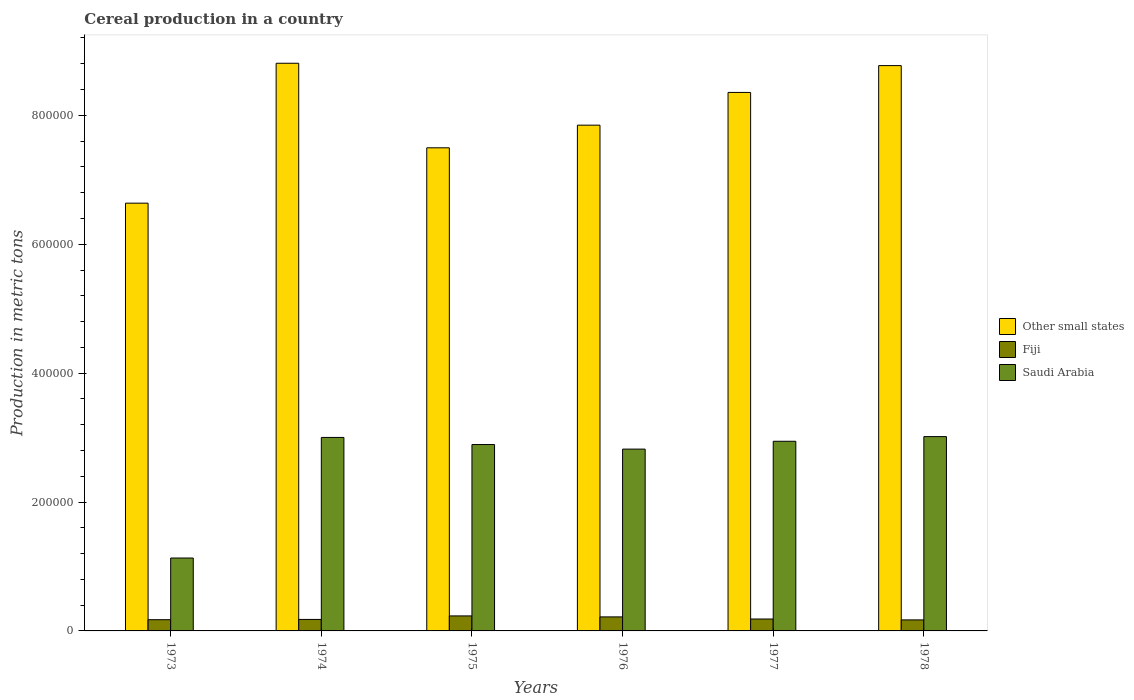How many different coloured bars are there?
Ensure brevity in your answer.  3. Are the number of bars on each tick of the X-axis equal?
Offer a terse response. Yes. How many bars are there on the 2nd tick from the left?
Offer a very short reply. 3. How many bars are there on the 4th tick from the right?
Give a very brief answer. 3. What is the label of the 3rd group of bars from the left?
Provide a succinct answer. 1975. What is the total cereal production in Fiji in 1976?
Offer a terse response. 2.18e+04. Across all years, what is the maximum total cereal production in Other small states?
Keep it short and to the point. 8.81e+05. Across all years, what is the minimum total cereal production in Other small states?
Offer a terse response. 6.64e+05. In which year was the total cereal production in Fiji maximum?
Offer a terse response. 1975. In which year was the total cereal production in Other small states minimum?
Make the answer very short. 1973. What is the total total cereal production in Other small states in the graph?
Your answer should be compact. 4.79e+06. What is the difference between the total cereal production in Fiji in 1974 and that in 1978?
Offer a very short reply. 715. What is the difference between the total cereal production in Saudi Arabia in 1977 and the total cereal production in Other small states in 1978?
Your answer should be very brief. -5.83e+05. What is the average total cereal production in Saudi Arabia per year?
Make the answer very short. 2.63e+05. In the year 1975, what is the difference between the total cereal production in Saudi Arabia and total cereal production in Other small states?
Your response must be concise. -4.60e+05. In how many years, is the total cereal production in Other small states greater than 320000 metric tons?
Offer a very short reply. 6. What is the ratio of the total cereal production in Other small states in 1975 to that in 1978?
Provide a short and direct response. 0.85. Is the total cereal production in Saudi Arabia in 1975 less than that in 1976?
Offer a terse response. No. Is the difference between the total cereal production in Saudi Arabia in 1974 and 1976 greater than the difference between the total cereal production in Other small states in 1974 and 1976?
Ensure brevity in your answer.  No. What is the difference between the highest and the second highest total cereal production in Other small states?
Your answer should be very brief. 3624. What is the difference between the highest and the lowest total cereal production in Other small states?
Your answer should be compact. 2.17e+05. In how many years, is the total cereal production in Other small states greater than the average total cereal production in Other small states taken over all years?
Your answer should be compact. 3. What does the 2nd bar from the left in 1978 represents?
Your response must be concise. Fiji. What does the 2nd bar from the right in 1978 represents?
Offer a very short reply. Fiji. Is it the case that in every year, the sum of the total cereal production in Other small states and total cereal production in Saudi Arabia is greater than the total cereal production in Fiji?
Your response must be concise. Yes. How many bars are there?
Your response must be concise. 18. Are all the bars in the graph horizontal?
Offer a very short reply. No. Are the values on the major ticks of Y-axis written in scientific E-notation?
Offer a very short reply. No. Does the graph contain any zero values?
Your answer should be compact. No. Where does the legend appear in the graph?
Keep it short and to the point. Center right. What is the title of the graph?
Your response must be concise. Cereal production in a country. What is the label or title of the Y-axis?
Provide a short and direct response. Production in metric tons. What is the Production in metric tons of Other small states in 1973?
Provide a succinct answer. 6.64e+05. What is the Production in metric tons in Fiji in 1973?
Give a very brief answer. 1.74e+04. What is the Production in metric tons of Saudi Arabia in 1973?
Your answer should be very brief. 1.13e+05. What is the Production in metric tons in Other small states in 1974?
Give a very brief answer. 8.81e+05. What is the Production in metric tons of Fiji in 1974?
Offer a very short reply. 1.78e+04. What is the Production in metric tons in Saudi Arabia in 1974?
Offer a terse response. 3.00e+05. What is the Production in metric tons in Other small states in 1975?
Your answer should be very brief. 7.50e+05. What is the Production in metric tons in Fiji in 1975?
Offer a terse response. 2.33e+04. What is the Production in metric tons of Saudi Arabia in 1975?
Make the answer very short. 2.89e+05. What is the Production in metric tons of Other small states in 1976?
Make the answer very short. 7.85e+05. What is the Production in metric tons of Fiji in 1976?
Offer a terse response. 2.18e+04. What is the Production in metric tons of Saudi Arabia in 1976?
Offer a very short reply. 2.82e+05. What is the Production in metric tons of Other small states in 1977?
Your response must be concise. 8.36e+05. What is the Production in metric tons of Fiji in 1977?
Provide a succinct answer. 1.85e+04. What is the Production in metric tons of Saudi Arabia in 1977?
Offer a terse response. 2.94e+05. What is the Production in metric tons in Other small states in 1978?
Ensure brevity in your answer.  8.77e+05. What is the Production in metric tons of Fiji in 1978?
Your answer should be very brief. 1.71e+04. What is the Production in metric tons in Saudi Arabia in 1978?
Keep it short and to the point. 3.02e+05. Across all years, what is the maximum Production in metric tons of Other small states?
Ensure brevity in your answer.  8.81e+05. Across all years, what is the maximum Production in metric tons of Fiji?
Offer a very short reply. 2.33e+04. Across all years, what is the maximum Production in metric tons in Saudi Arabia?
Your answer should be very brief. 3.02e+05. Across all years, what is the minimum Production in metric tons in Other small states?
Ensure brevity in your answer.  6.64e+05. Across all years, what is the minimum Production in metric tons of Fiji?
Provide a succinct answer. 1.71e+04. Across all years, what is the minimum Production in metric tons of Saudi Arabia?
Offer a terse response. 1.13e+05. What is the total Production in metric tons of Other small states in the graph?
Ensure brevity in your answer.  4.79e+06. What is the total Production in metric tons of Fiji in the graph?
Offer a terse response. 1.16e+05. What is the total Production in metric tons in Saudi Arabia in the graph?
Your answer should be very brief. 1.58e+06. What is the difference between the Production in metric tons of Other small states in 1973 and that in 1974?
Provide a short and direct response. -2.17e+05. What is the difference between the Production in metric tons in Fiji in 1973 and that in 1974?
Keep it short and to the point. -407. What is the difference between the Production in metric tons of Saudi Arabia in 1973 and that in 1974?
Offer a very short reply. -1.87e+05. What is the difference between the Production in metric tons of Other small states in 1973 and that in 1975?
Offer a very short reply. -8.59e+04. What is the difference between the Production in metric tons in Fiji in 1973 and that in 1975?
Offer a very short reply. -5880. What is the difference between the Production in metric tons in Saudi Arabia in 1973 and that in 1975?
Offer a very short reply. -1.76e+05. What is the difference between the Production in metric tons in Other small states in 1973 and that in 1976?
Ensure brevity in your answer.  -1.21e+05. What is the difference between the Production in metric tons of Fiji in 1973 and that in 1976?
Provide a short and direct response. -4355. What is the difference between the Production in metric tons in Saudi Arabia in 1973 and that in 1976?
Keep it short and to the point. -1.69e+05. What is the difference between the Production in metric tons of Other small states in 1973 and that in 1977?
Ensure brevity in your answer.  -1.72e+05. What is the difference between the Production in metric tons in Fiji in 1973 and that in 1977?
Provide a short and direct response. -1062. What is the difference between the Production in metric tons of Saudi Arabia in 1973 and that in 1977?
Provide a succinct answer. -1.81e+05. What is the difference between the Production in metric tons in Other small states in 1973 and that in 1978?
Make the answer very short. -2.13e+05. What is the difference between the Production in metric tons in Fiji in 1973 and that in 1978?
Provide a short and direct response. 308. What is the difference between the Production in metric tons in Saudi Arabia in 1973 and that in 1978?
Your answer should be very brief. -1.88e+05. What is the difference between the Production in metric tons in Other small states in 1974 and that in 1975?
Provide a short and direct response. 1.31e+05. What is the difference between the Production in metric tons of Fiji in 1974 and that in 1975?
Provide a short and direct response. -5473. What is the difference between the Production in metric tons of Saudi Arabia in 1974 and that in 1975?
Provide a succinct answer. 1.10e+04. What is the difference between the Production in metric tons in Other small states in 1974 and that in 1976?
Offer a very short reply. 9.61e+04. What is the difference between the Production in metric tons of Fiji in 1974 and that in 1976?
Your response must be concise. -3948. What is the difference between the Production in metric tons in Saudi Arabia in 1974 and that in 1976?
Offer a terse response. 1.81e+04. What is the difference between the Production in metric tons of Other small states in 1974 and that in 1977?
Provide a succinct answer. 4.53e+04. What is the difference between the Production in metric tons of Fiji in 1974 and that in 1977?
Provide a succinct answer. -655. What is the difference between the Production in metric tons of Saudi Arabia in 1974 and that in 1977?
Offer a terse response. 5965. What is the difference between the Production in metric tons of Other small states in 1974 and that in 1978?
Offer a terse response. 3624. What is the difference between the Production in metric tons in Fiji in 1974 and that in 1978?
Offer a very short reply. 715. What is the difference between the Production in metric tons of Saudi Arabia in 1974 and that in 1978?
Your answer should be very brief. -1283. What is the difference between the Production in metric tons in Other small states in 1975 and that in 1976?
Keep it short and to the point. -3.51e+04. What is the difference between the Production in metric tons of Fiji in 1975 and that in 1976?
Give a very brief answer. 1525. What is the difference between the Production in metric tons of Saudi Arabia in 1975 and that in 1976?
Ensure brevity in your answer.  7080. What is the difference between the Production in metric tons of Other small states in 1975 and that in 1977?
Provide a short and direct response. -8.59e+04. What is the difference between the Production in metric tons in Fiji in 1975 and that in 1977?
Keep it short and to the point. 4818. What is the difference between the Production in metric tons of Saudi Arabia in 1975 and that in 1977?
Your answer should be very brief. -5085. What is the difference between the Production in metric tons of Other small states in 1975 and that in 1978?
Your response must be concise. -1.28e+05. What is the difference between the Production in metric tons of Fiji in 1975 and that in 1978?
Your response must be concise. 6188. What is the difference between the Production in metric tons in Saudi Arabia in 1975 and that in 1978?
Provide a succinct answer. -1.23e+04. What is the difference between the Production in metric tons in Other small states in 1976 and that in 1977?
Make the answer very short. -5.08e+04. What is the difference between the Production in metric tons in Fiji in 1976 and that in 1977?
Ensure brevity in your answer.  3293. What is the difference between the Production in metric tons of Saudi Arabia in 1976 and that in 1977?
Ensure brevity in your answer.  -1.22e+04. What is the difference between the Production in metric tons in Other small states in 1976 and that in 1978?
Keep it short and to the point. -9.24e+04. What is the difference between the Production in metric tons of Fiji in 1976 and that in 1978?
Your answer should be very brief. 4663. What is the difference between the Production in metric tons in Saudi Arabia in 1976 and that in 1978?
Ensure brevity in your answer.  -1.94e+04. What is the difference between the Production in metric tons of Other small states in 1977 and that in 1978?
Offer a terse response. -4.16e+04. What is the difference between the Production in metric tons of Fiji in 1977 and that in 1978?
Offer a very short reply. 1370. What is the difference between the Production in metric tons of Saudi Arabia in 1977 and that in 1978?
Offer a terse response. -7248. What is the difference between the Production in metric tons of Other small states in 1973 and the Production in metric tons of Fiji in 1974?
Your response must be concise. 6.46e+05. What is the difference between the Production in metric tons in Other small states in 1973 and the Production in metric tons in Saudi Arabia in 1974?
Offer a very short reply. 3.63e+05. What is the difference between the Production in metric tons in Fiji in 1973 and the Production in metric tons in Saudi Arabia in 1974?
Give a very brief answer. -2.83e+05. What is the difference between the Production in metric tons in Other small states in 1973 and the Production in metric tons in Fiji in 1975?
Offer a terse response. 6.40e+05. What is the difference between the Production in metric tons in Other small states in 1973 and the Production in metric tons in Saudi Arabia in 1975?
Provide a succinct answer. 3.75e+05. What is the difference between the Production in metric tons of Fiji in 1973 and the Production in metric tons of Saudi Arabia in 1975?
Keep it short and to the point. -2.72e+05. What is the difference between the Production in metric tons in Other small states in 1973 and the Production in metric tons in Fiji in 1976?
Ensure brevity in your answer.  6.42e+05. What is the difference between the Production in metric tons in Other small states in 1973 and the Production in metric tons in Saudi Arabia in 1976?
Ensure brevity in your answer.  3.82e+05. What is the difference between the Production in metric tons in Fiji in 1973 and the Production in metric tons in Saudi Arabia in 1976?
Offer a very short reply. -2.65e+05. What is the difference between the Production in metric tons in Other small states in 1973 and the Production in metric tons in Fiji in 1977?
Offer a very short reply. 6.45e+05. What is the difference between the Production in metric tons in Other small states in 1973 and the Production in metric tons in Saudi Arabia in 1977?
Your answer should be compact. 3.69e+05. What is the difference between the Production in metric tons of Fiji in 1973 and the Production in metric tons of Saudi Arabia in 1977?
Make the answer very short. -2.77e+05. What is the difference between the Production in metric tons of Other small states in 1973 and the Production in metric tons of Fiji in 1978?
Your response must be concise. 6.47e+05. What is the difference between the Production in metric tons of Other small states in 1973 and the Production in metric tons of Saudi Arabia in 1978?
Ensure brevity in your answer.  3.62e+05. What is the difference between the Production in metric tons of Fiji in 1973 and the Production in metric tons of Saudi Arabia in 1978?
Your answer should be compact. -2.84e+05. What is the difference between the Production in metric tons of Other small states in 1974 and the Production in metric tons of Fiji in 1975?
Your answer should be compact. 8.58e+05. What is the difference between the Production in metric tons of Other small states in 1974 and the Production in metric tons of Saudi Arabia in 1975?
Your answer should be very brief. 5.92e+05. What is the difference between the Production in metric tons in Fiji in 1974 and the Production in metric tons in Saudi Arabia in 1975?
Give a very brief answer. -2.71e+05. What is the difference between the Production in metric tons of Other small states in 1974 and the Production in metric tons of Fiji in 1976?
Your answer should be very brief. 8.59e+05. What is the difference between the Production in metric tons in Other small states in 1974 and the Production in metric tons in Saudi Arabia in 1976?
Provide a short and direct response. 5.99e+05. What is the difference between the Production in metric tons of Fiji in 1974 and the Production in metric tons of Saudi Arabia in 1976?
Your response must be concise. -2.64e+05. What is the difference between the Production in metric tons of Other small states in 1974 and the Production in metric tons of Fiji in 1977?
Your answer should be very brief. 8.62e+05. What is the difference between the Production in metric tons of Other small states in 1974 and the Production in metric tons of Saudi Arabia in 1977?
Your response must be concise. 5.87e+05. What is the difference between the Production in metric tons in Fiji in 1974 and the Production in metric tons in Saudi Arabia in 1977?
Your answer should be very brief. -2.76e+05. What is the difference between the Production in metric tons in Other small states in 1974 and the Production in metric tons in Fiji in 1978?
Make the answer very short. 8.64e+05. What is the difference between the Production in metric tons in Other small states in 1974 and the Production in metric tons in Saudi Arabia in 1978?
Your answer should be compact. 5.79e+05. What is the difference between the Production in metric tons in Fiji in 1974 and the Production in metric tons in Saudi Arabia in 1978?
Offer a terse response. -2.84e+05. What is the difference between the Production in metric tons of Other small states in 1975 and the Production in metric tons of Fiji in 1976?
Provide a short and direct response. 7.28e+05. What is the difference between the Production in metric tons of Other small states in 1975 and the Production in metric tons of Saudi Arabia in 1976?
Provide a short and direct response. 4.68e+05. What is the difference between the Production in metric tons in Fiji in 1975 and the Production in metric tons in Saudi Arabia in 1976?
Keep it short and to the point. -2.59e+05. What is the difference between the Production in metric tons in Other small states in 1975 and the Production in metric tons in Fiji in 1977?
Offer a very short reply. 7.31e+05. What is the difference between the Production in metric tons in Other small states in 1975 and the Production in metric tons in Saudi Arabia in 1977?
Make the answer very short. 4.55e+05. What is the difference between the Production in metric tons in Fiji in 1975 and the Production in metric tons in Saudi Arabia in 1977?
Keep it short and to the point. -2.71e+05. What is the difference between the Production in metric tons in Other small states in 1975 and the Production in metric tons in Fiji in 1978?
Your answer should be very brief. 7.33e+05. What is the difference between the Production in metric tons of Other small states in 1975 and the Production in metric tons of Saudi Arabia in 1978?
Your answer should be compact. 4.48e+05. What is the difference between the Production in metric tons in Fiji in 1975 and the Production in metric tons in Saudi Arabia in 1978?
Your answer should be very brief. -2.78e+05. What is the difference between the Production in metric tons in Other small states in 1976 and the Production in metric tons in Fiji in 1977?
Make the answer very short. 7.66e+05. What is the difference between the Production in metric tons of Other small states in 1976 and the Production in metric tons of Saudi Arabia in 1977?
Make the answer very short. 4.90e+05. What is the difference between the Production in metric tons of Fiji in 1976 and the Production in metric tons of Saudi Arabia in 1977?
Offer a very short reply. -2.73e+05. What is the difference between the Production in metric tons in Other small states in 1976 and the Production in metric tons in Fiji in 1978?
Ensure brevity in your answer.  7.68e+05. What is the difference between the Production in metric tons of Other small states in 1976 and the Production in metric tons of Saudi Arabia in 1978?
Your response must be concise. 4.83e+05. What is the difference between the Production in metric tons of Fiji in 1976 and the Production in metric tons of Saudi Arabia in 1978?
Provide a short and direct response. -2.80e+05. What is the difference between the Production in metric tons of Other small states in 1977 and the Production in metric tons of Fiji in 1978?
Keep it short and to the point. 8.18e+05. What is the difference between the Production in metric tons of Other small states in 1977 and the Production in metric tons of Saudi Arabia in 1978?
Offer a terse response. 5.34e+05. What is the difference between the Production in metric tons of Fiji in 1977 and the Production in metric tons of Saudi Arabia in 1978?
Your answer should be compact. -2.83e+05. What is the average Production in metric tons in Other small states per year?
Provide a succinct answer. 7.99e+05. What is the average Production in metric tons in Fiji per year?
Give a very brief answer. 1.93e+04. What is the average Production in metric tons of Saudi Arabia per year?
Keep it short and to the point. 2.63e+05. In the year 1973, what is the difference between the Production in metric tons in Other small states and Production in metric tons in Fiji?
Provide a succinct answer. 6.46e+05. In the year 1973, what is the difference between the Production in metric tons in Other small states and Production in metric tons in Saudi Arabia?
Keep it short and to the point. 5.51e+05. In the year 1973, what is the difference between the Production in metric tons in Fiji and Production in metric tons in Saudi Arabia?
Ensure brevity in your answer.  -9.57e+04. In the year 1974, what is the difference between the Production in metric tons of Other small states and Production in metric tons of Fiji?
Offer a terse response. 8.63e+05. In the year 1974, what is the difference between the Production in metric tons of Other small states and Production in metric tons of Saudi Arabia?
Give a very brief answer. 5.81e+05. In the year 1974, what is the difference between the Production in metric tons in Fiji and Production in metric tons in Saudi Arabia?
Provide a succinct answer. -2.82e+05. In the year 1975, what is the difference between the Production in metric tons in Other small states and Production in metric tons in Fiji?
Provide a short and direct response. 7.26e+05. In the year 1975, what is the difference between the Production in metric tons of Other small states and Production in metric tons of Saudi Arabia?
Your answer should be very brief. 4.60e+05. In the year 1975, what is the difference between the Production in metric tons in Fiji and Production in metric tons in Saudi Arabia?
Give a very brief answer. -2.66e+05. In the year 1976, what is the difference between the Production in metric tons of Other small states and Production in metric tons of Fiji?
Your response must be concise. 7.63e+05. In the year 1976, what is the difference between the Production in metric tons in Other small states and Production in metric tons in Saudi Arabia?
Make the answer very short. 5.03e+05. In the year 1976, what is the difference between the Production in metric tons in Fiji and Production in metric tons in Saudi Arabia?
Your response must be concise. -2.60e+05. In the year 1977, what is the difference between the Production in metric tons in Other small states and Production in metric tons in Fiji?
Provide a succinct answer. 8.17e+05. In the year 1977, what is the difference between the Production in metric tons in Other small states and Production in metric tons in Saudi Arabia?
Provide a succinct answer. 5.41e+05. In the year 1977, what is the difference between the Production in metric tons in Fiji and Production in metric tons in Saudi Arabia?
Your response must be concise. -2.76e+05. In the year 1978, what is the difference between the Production in metric tons in Other small states and Production in metric tons in Fiji?
Your response must be concise. 8.60e+05. In the year 1978, what is the difference between the Production in metric tons in Other small states and Production in metric tons in Saudi Arabia?
Make the answer very short. 5.76e+05. In the year 1978, what is the difference between the Production in metric tons of Fiji and Production in metric tons of Saudi Arabia?
Your response must be concise. -2.84e+05. What is the ratio of the Production in metric tons of Other small states in 1973 to that in 1974?
Your answer should be very brief. 0.75. What is the ratio of the Production in metric tons in Fiji in 1973 to that in 1974?
Make the answer very short. 0.98. What is the ratio of the Production in metric tons of Saudi Arabia in 1973 to that in 1974?
Your answer should be very brief. 0.38. What is the ratio of the Production in metric tons of Other small states in 1973 to that in 1975?
Keep it short and to the point. 0.89. What is the ratio of the Production in metric tons in Fiji in 1973 to that in 1975?
Offer a very short reply. 0.75. What is the ratio of the Production in metric tons in Saudi Arabia in 1973 to that in 1975?
Provide a short and direct response. 0.39. What is the ratio of the Production in metric tons in Other small states in 1973 to that in 1976?
Provide a succinct answer. 0.85. What is the ratio of the Production in metric tons of Fiji in 1973 to that in 1976?
Provide a short and direct response. 0.8. What is the ratio of the Production in metric tons in Saudi Arabia in 1973 to that in 1976?
Your answer should be very brief. 0.4. What is the ratio of the Production in metric tons of Other small states in 1973 to that in 1977?
Ensure brevity in your answer.  0.79. What is the ratio of the Production in metric tons of Fiji in 1973 to that in 1977?
Ensure brevity in your answer.  0.94. What is the ratio of the Production in metric tons in Saudi Arabia in 1973 to that in 1977?
Provide a short and direct response. 0.38. What is the ratio of the Production in metric tons in Other small states in 1973 to that in 1978?
Your answer should be compact. 0.76. What is the ratio of the Production in metric tons of Saudi Arabia in 1973 to that in 1978?
Your response must be concise. 0.38. What is the ratio of the Production in metric tons of Other small states in 1974 to that in 1975?
Offer a terse response. 1.18. What is the ratio of the Production in metric tons of Fiji in 1974 to that in 1975?
Offer a terse response. 0.77. What is the ratio of the Production in metric tons of Saudi Arabia in 1974 to that in 1975?
Provide a succinct answer. 1.04. What is the ratio of the Production in metric tons in Other small states in 1974 to that in 1976?
Your response must be concise. 1.12. What is the ratio of the Production in metric tons of Fiji in 1974 to that in 1976?
Offer a very short reply. 0.82. What is the ratio of the Production in metric tons of Saudi Arabia in 1974 to that in 1976?
Your response must be concise. 1.06. What is the ratio of the Production in metric tons of Other small states in 1974 to that in 1977?
Provide a short and direct response. 1.05. What is the ratio of the Production in metric tons in Fiji in 1974 to that in 1977?
Provide a short and direct response. 0.96. What is the ratio of the Production in metric tons in Saudi Arabia in 1974 to that in 1977?
Make the answer very short. 1.02. What is the ratio of the Production in metric tons in Fiji in 1974 to that in 1978?
Your answer should be very brief. 1.04. What is the ratio of the Production in metric tons of Saudi Arabia in 1974 to that in 1978?
Ensure brevity in your answer.  1. What is the ratio of the Production in metric tons of Other small states in 1975 to that in 1976?
Your answer should be very brief. 0.96. What is the ratio of the Production in metric tons in Fiji in 1975 to that in 1976?
Your answer should be very brief. 1.07. What is the ratio of the Production in metric tons of Saudi Arabia in 1975 to that in 1976?
Your answer should be compact. 1.03. What is the ratio of the Production in metric tons in Other small states in 1975 to that in 1977?
Offer a terse response. 0.9. What is the ratio of the Production in metric tons of Fiji in 1975 to that in 1977?
Offer a very short reply. 1.26. What is the ratio of the Production in metric tons in Saudi Arabia in 1975 to that in 1977?
Your response must be concise. 0.98. What is the ratio of the Production in metric tons in Other small states in 1975 to that in 1978?
Provide a succinct answer. 0.85. What is the ratio of the Production in metric tons of Fiji in 1975 to that in 1978?
Offer a terse response. 1.36. What is the ratio of the Production in metric tons in Saudi Arabia in 1975 to that in 1978?
Give a very brief answer. 0.96. What is the ratio of the Production in metric tons of Other small states in 1976 to that in 1977?
Your response must be concise. 0.94. What is the ratio of the Production in metric tons in Fiji in 1976 to that in 1977?
Provide a succinct answer. 1.18. What is the ratio of the Production in metric tons in Saudi Arabia in 1976 to that in 1977?
Give a very brief answer. 0.96. What is the ratio of the Production in metric tons of Other small states in 1976 to that in 1978?
Provide a succinct answer. 0.89. What is the ratio of the Production in metric tons of Fiji in 1976 to that in 1978?
Provide a short and direct response. 1.27. What is the ratio of the Production in metric tons in Saudi Arabia in 1976 to that in 1978?
Make the answer very short. 0.94. What is the ratio of the Production in metric tons in Other small states in 1977 to that in 1978?
Provide a short and direct response. 0.95. What is the ratio of the Production in metric tons of Fiji in 1977 to that in 1978?
Provide a short and direct response. 1.08. What is the ratio of the Production in metric tons of Saudi Arabia in 1977 to that in 1978?
Offer a terse response. 0.98. What is the difference between the highest and the second highest Production in metric tons in Other small states?
Your answer should be compact. 3624. What is the difference between the highest and the second highest Production in metric tons in Fiji?
Offer a very short reply. 1525. What is the difference between the highest and the second highest Production in metric tons in Saudi Arabia?
Offer a very short reply. 1283. What is the difference between the highest and the lowest Production in metric tons in Other small states?
Your answer should be very brief. 2.17e+05. What is the difference between the highest and the lowest Production in metric tons of Fiji?
Offer a very short reply. 6188. What is the difference between the highest and the lowest Production in metric tons in Saudi Arabia?
Ensure brevity in your answer.  1.88e+05. 